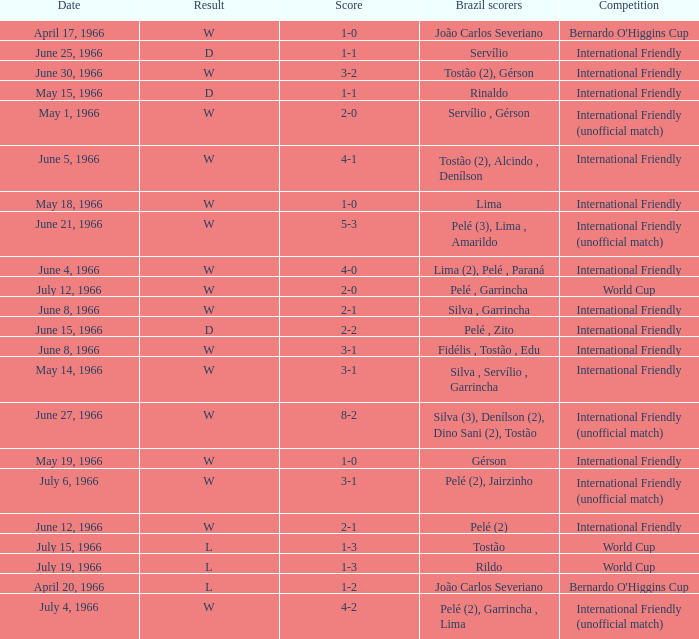What competition has a result of W on June 30, 1966? International Friendly. 